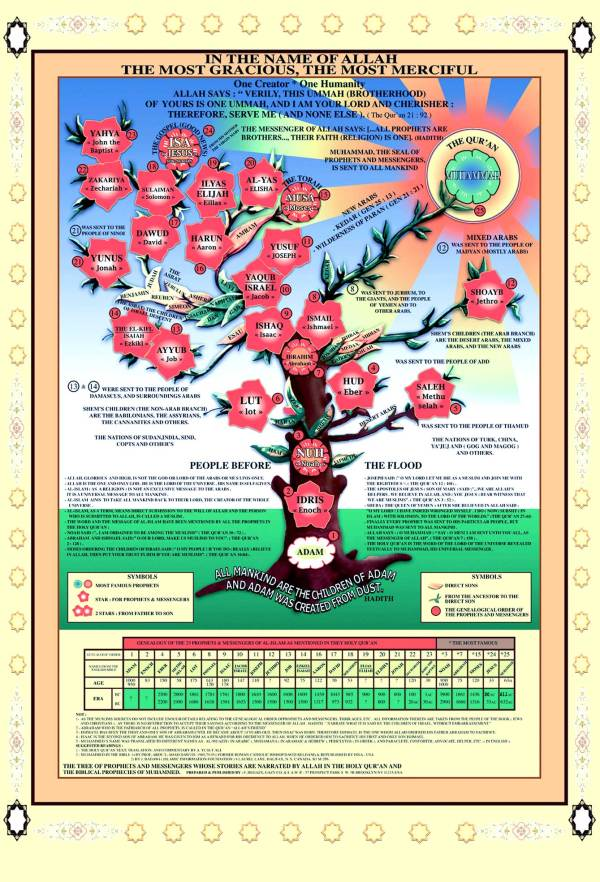Can you explain the significance of the different colors used in the branches of this tree? The varying colors on the branches of the tree likely represent different epochs or significant shifts in prophetic lineage. For example, warmer colors such as red and orange might denote major prophets who are central to Islamic faith, such as Moses and Jesus, while cooler colors like green could indicate prophets who played roles in specific regional contexts or who are lesser known in the broader Islamic narrative. This color coding helps in visually distinguishing between the major and minor prophets, and possibly indicating periods of peace or turmoil during their times. 